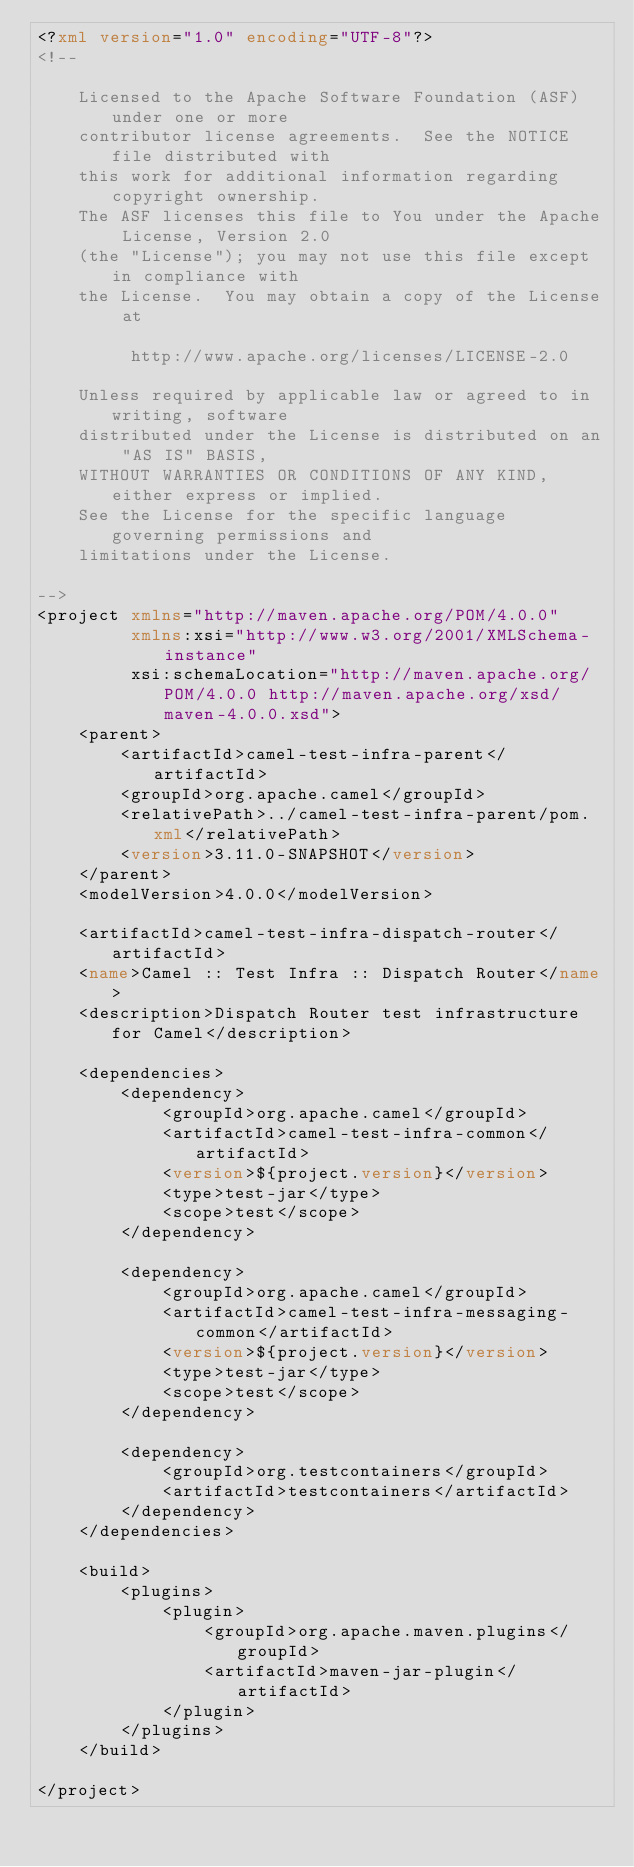<code> <loc_0><loc_0><loc_500><loc_500><_XML_><?xml version="1.0" encoding="UTF-8"?>
<!--

    Licensed to the Apache Software Foundation (ASF) under one or more
    contributor license agreements.  See the NOTICE file distributed with
    this work for additional information regarding copyright ownership.
    The ASF licenses this file to You under the Apache License, Version 2.0
    (the "License"); you may not use this file except in compliance with
    the License.  You may obtain a copy of the License at

         http://www.apache.org/licenses/LICENSE-2.0

    Unless required by applicable law or agreed to in writing, software
    distributed under the License is distributed on an "AS IS" BASIS,
    WITHOUT WARRANTIES OR CONDITIONS OF ANY KIND, either express or implied.
    See the License for the specific language governing permissions and
    limitations under the License.

-->
<project xmlns="http://maven.apache.org/POM/4.0.0"
         xmlns:xsi="http://www.w3.org/2001/XMLSchema-instance"
         xsi:schemaLocation="http://maven.apache.org/POM/4.0.0 http://maven.apache.org/xsd/maven-4.0.0.xsd">
    <parent>
        <artifactId>camel-test-infra-parent</artifactId>
        <groupId>org.apache.camel</groupId>
        <relativePath>../camel-test-infra-parent/pom.xml</relativePath>
        <version>3.11.0-SNAPSHOT</version>
    </parent>
    <modelVersion>4.0.0</modelVersion>

    <artifactId>camel-test-infra-dispatch-router</artifactId>
    <name>Camel :: Test Infra :: Dispatch Router</name>
    <description>Dispatch Router test infrastructure for Camel</description>

    <dependencies>
        <dependency>
            <groupId>org.apache.camel</groupId>
            <artifactId>camel-test-infra-common</artifactId>
            <version>${project.version}</version>
            <type>test-jar</type>
            <scope>test</scope>
        </dependency>

        <dependency>
            <groupId>org.apache.camel</groupId>
            <artifactId>camel-test-infra-messaging-common</artifactId>
            <version>${project.version}</version>
            <type>test-jar</type>
            <scope>test</scope>
        </dependency>

        <dependency>
            <groupId>org.testcontainers</groupId>
            <artifactId>testcontainers</artifactId>
        </dependency>
    </dependencies>

    <build>
        <plugins>
            <plugin>
                <groupId>org.apache.maven.plugins</groupId>
                <artifactId>maven-jar-plugin</artifactId>
            </plugin>
        </plugins>
    </build>

</project></code> 